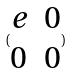Convert formula to latex. <formula><loc_0><loc_0><loc_500><loc_500>( \begin{matrix} e & 0 \\ 0 & 0 \end{matrix} )</formula> 